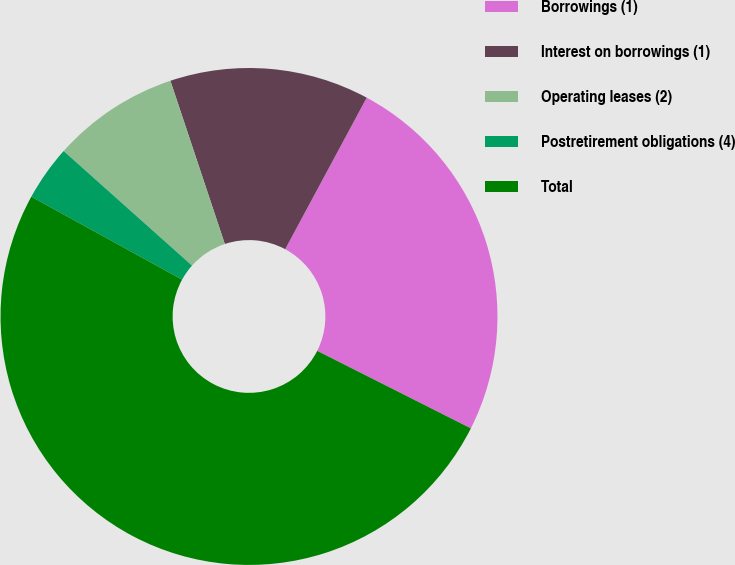Convert chart. <chart><loc_0><loc_0><loc_500><loc_500><pie_chart><fcel>Borrowings (1)<fcel>Interest on borrowings (1)<fcel>Operating leases (2)<fcel>Postretirement obligations (4)<fcel>Total<nl><fcel>24.58%<fcel>12.98%<fcel>8.28%<fcel>3.59%<fcel>50.57%<nl></chart> 